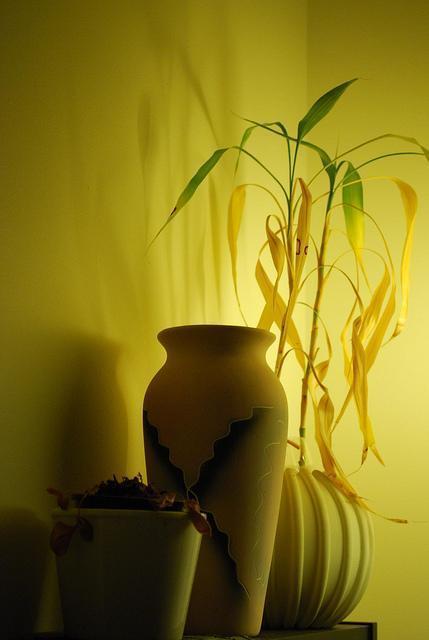How many vases can you see?
Give a very brief answer. 2. How many potted plants are visible?
Give a very brief answer. 2. How many people have pink hair?
Give a very brief answer. 0. 